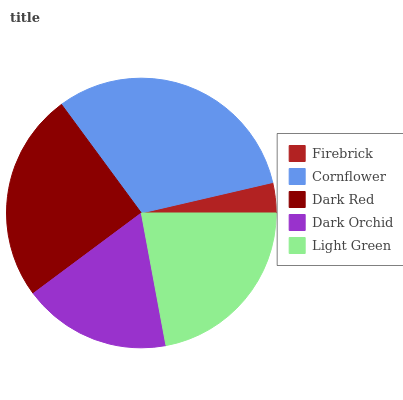Is Firebrick the minimum?
Answer yes or no. Yes. Is Cornflower the maximum?
Answer yes or no. Yes. Is Dark Red the minimum?
Answer yes or no. No. Is Dark Red the maximum?
Answer yes or no. No. Is Cornflower greater than Dark Red?
Answer yes or no. Yes. Is Dark Red less than Cornflower?
Answer yes or no. Yes. Is Dark Red greater than Cornflower?
Answer yes or no. No. Is Cornflower less than Dark Red?
Answer yes or no. No. Is Light Green the high median?
Answer yes or no. Yes. Is Light Green the low median?
Answer yes or no. Yes. Is Dark Red the high median?
Answer yes or no. No. Is Dark Red the low median?
Answer yes or no. No. 